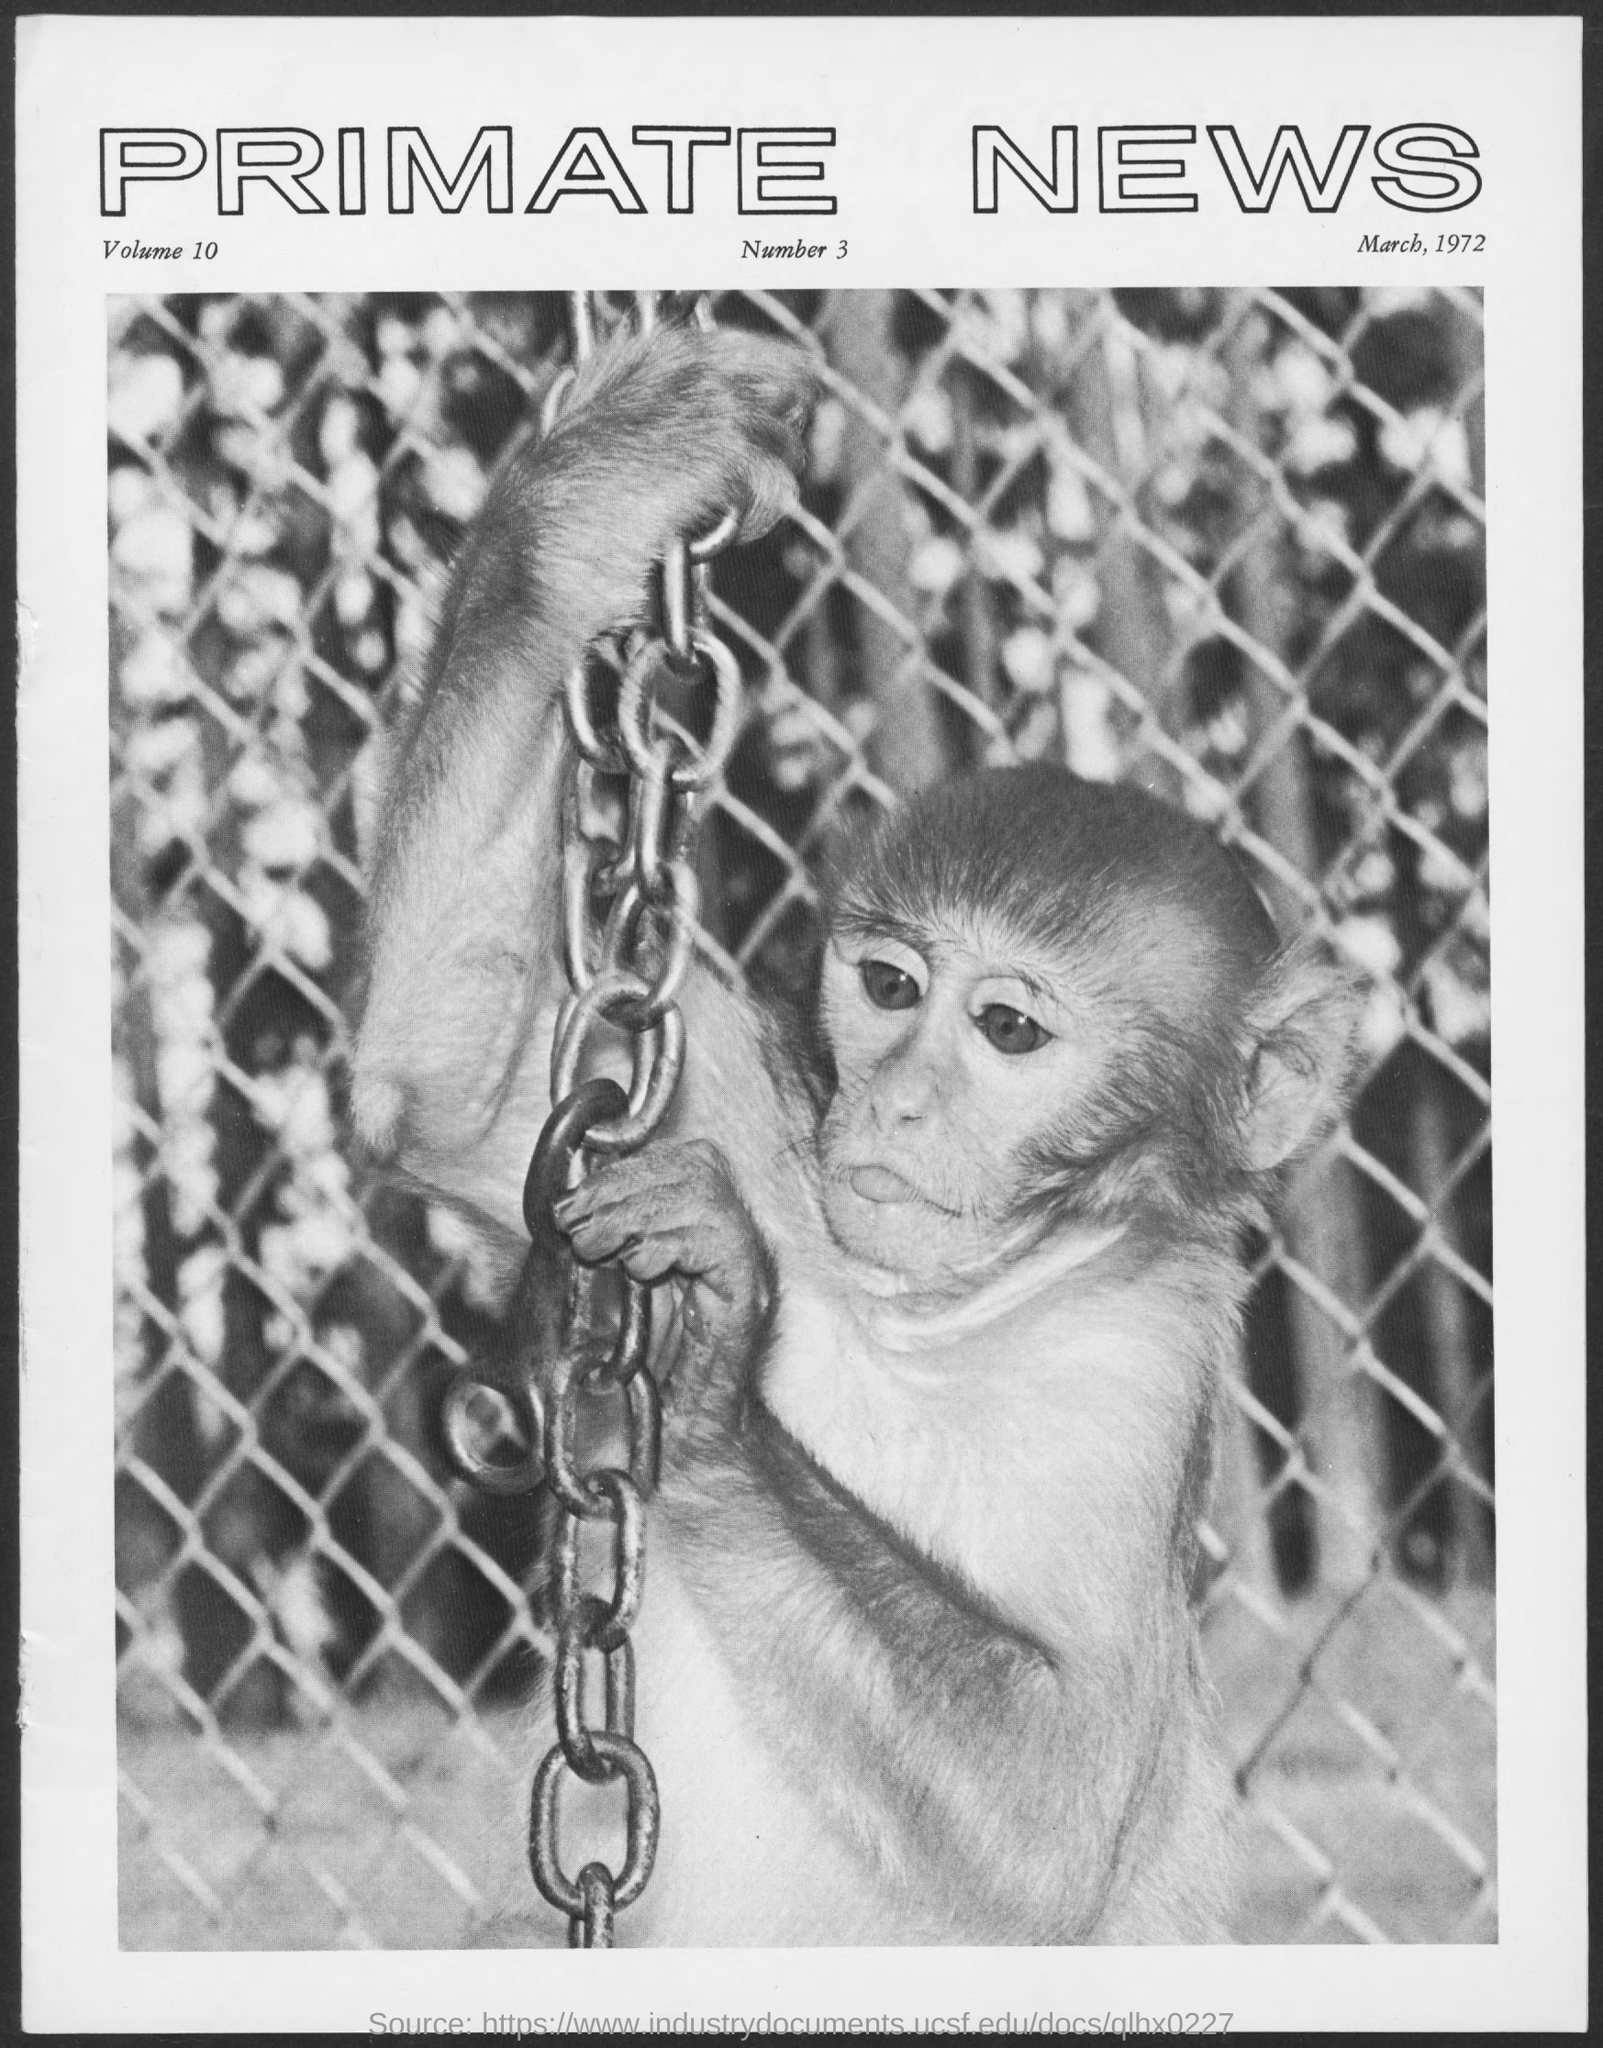What is the Title of the document?
Offer a terse response. PRIMATE NEWS. What is the date on the document?
Give a very brief answer. March, 1972. What is the Volume?
Offer a very short reply. 10. What is the Number?
Provide a succinct answer. 3. 